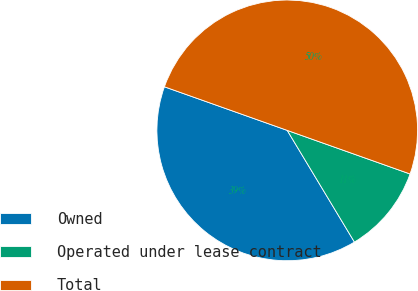Convert chart to OTSL. <chart><loc_0><loc_0><loc_500><loc_500><pie_chart><fcel>Owned<fcel>Operated under lease contract<fcel>Total<nl><fcel>39.05%<fcel>10.95%<fcel>50.0%<nl></chart> 